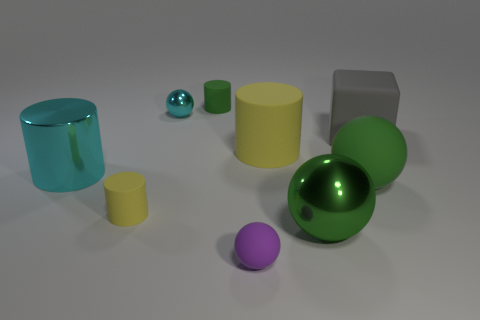Add 1 matte balls. How many objects exist? 10 Subtract all cyan metal balls. How many balls are left? 3 Subtract all red cylinders. How many green spheres are left? 2 Subtract all green spheres. How many spheres are left? 2 Add 7 tiny green cylinders. How many tiny green cylinders exist? 8 Subtract 0 purple cubes. How many objects are left? 9 Subtract all balls. How many objects are left? 5 Subtract all green balls. Subtract all brown cylinders. How many balls are left? 2 Subtract all big yellow things. Subtract all small cyan things. How many objects are left? 7 Add 3 big yellow cylinders. How many big yellow cylinders are left? 4 